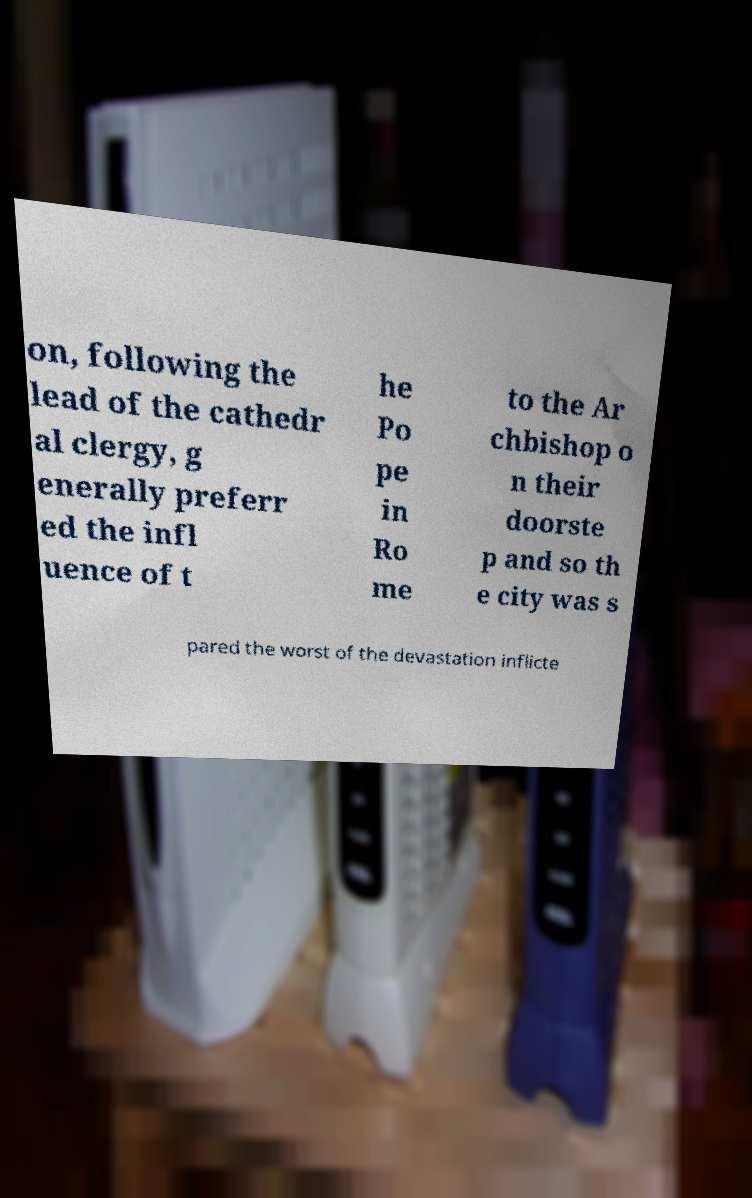Please read and relay the text visible in this image. What does it say? on, following the lead of the cathedr al clergy, g enerally preferr ed the infl uence of t he Po pe in Ro me to the Ar chbishop o n their doorste p and so th e city was s pared the worst of the devastation inflicte 